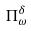<formula> <loc_0><loc_0><loc_500><loc_500>\Pi _ { \omega } ^ { \delta }</formula> 